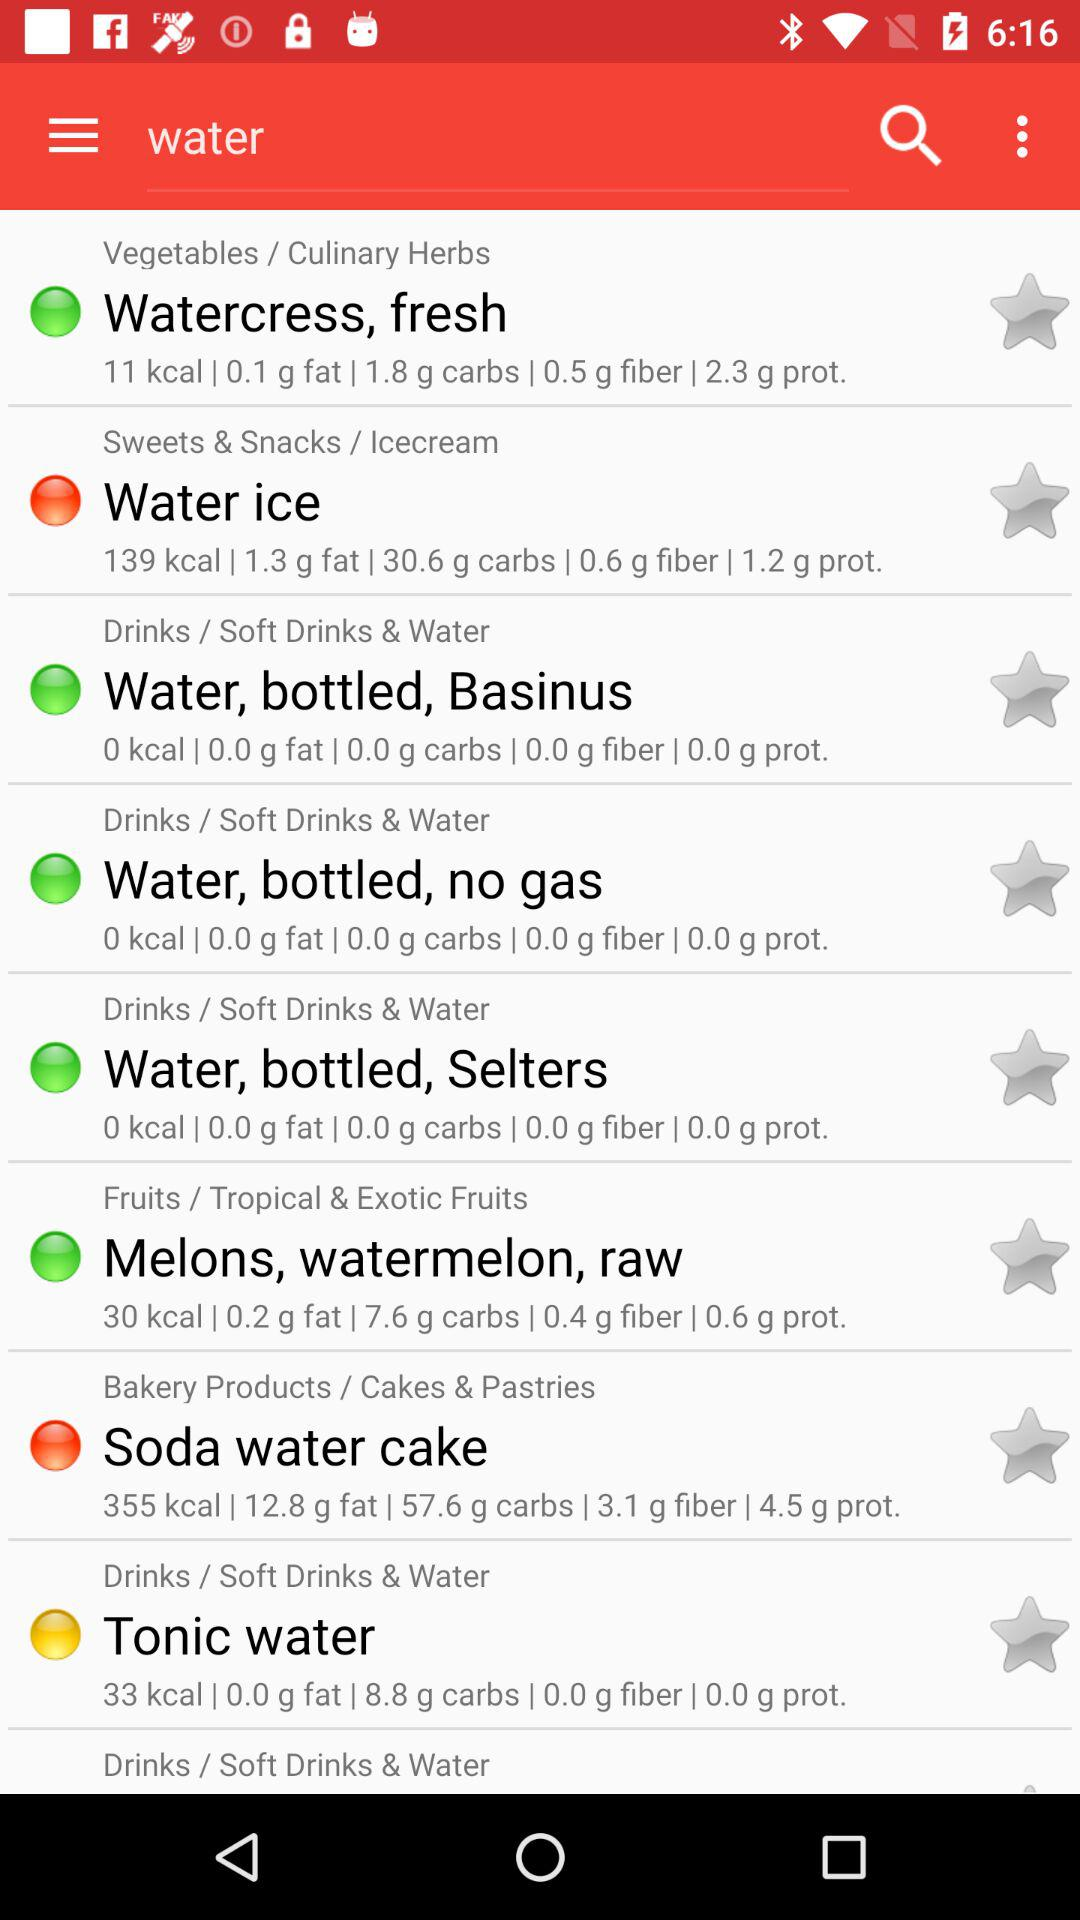Which water has 0.4 g of fiber?
When the provided information is insufficient, respond with <no answer>. <no answer> 